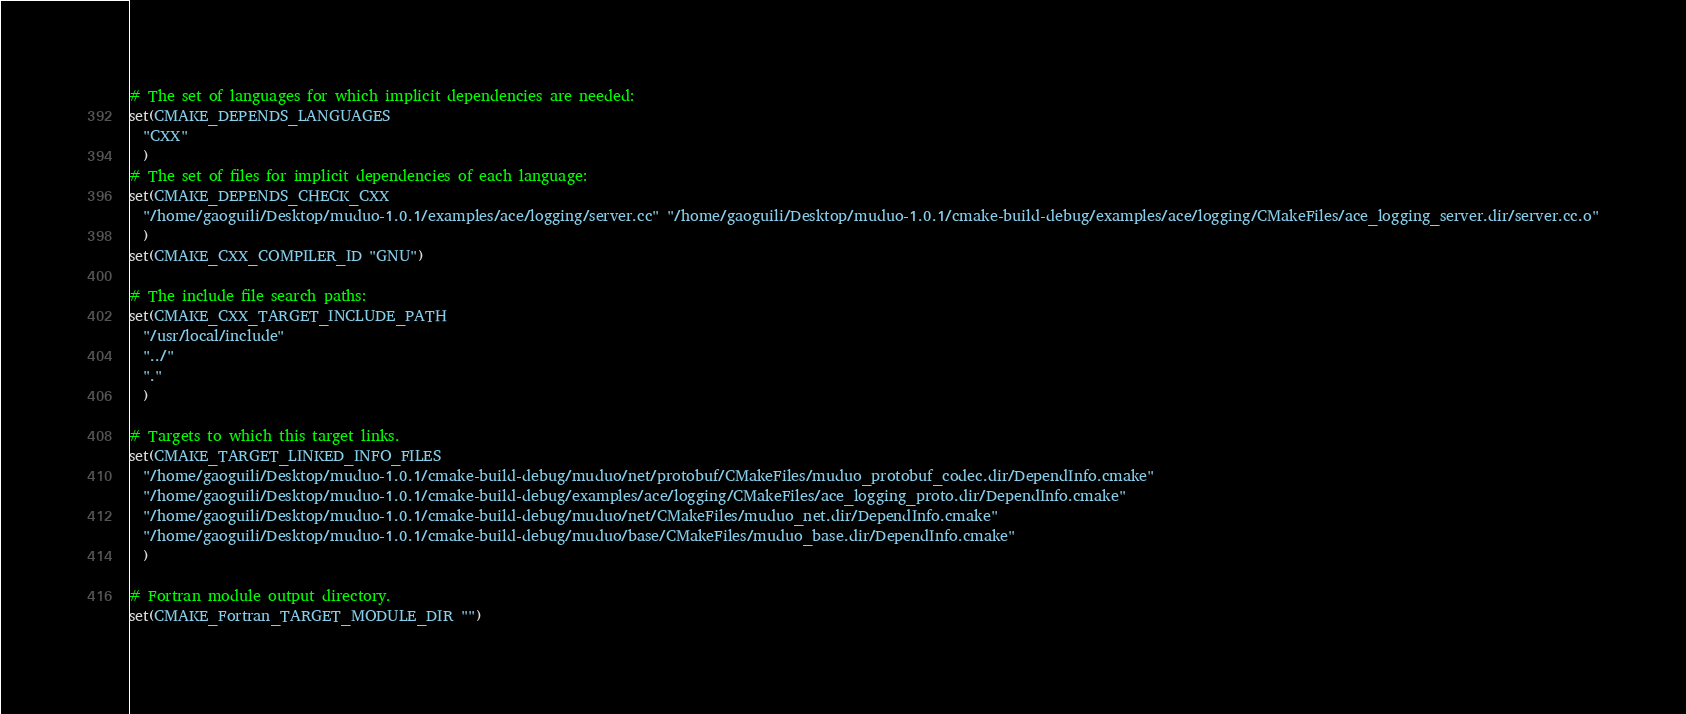Convert code to text. <code><loc_0><loc_0><loc_500><loc_500><_CMake_># The set of languages for which implicit dependencies are needed:
set(CMAKE_DEPENDS_LANGUAGES
  "CXX"
  )
# The set of files for implicit dependencies of each language:
set(CMAKE_DEPENDS_CHECK_CXX
  "/home/gaoguili/Desktop/muduo-1.0.1/examples/ace/logging/server.cc" "/home/gaoguili/Desktop/muduo-1.0.1/cmake-build-debug/examples/ace/logging/CMakeFiles/ace_logging_server.dir/server.cc.o"
  )
set(CMAKE_CXX_COMPILER_ID "GNU")

# The include file search paths:
set(CMAKE_CXX_TARGET_INCLUDE_PATH
  "/usr/local/include"
  "../"
  "."
  )

# Targets to which this target links.
set(CMAKE_TARGET_LINKED_INFO_FILES
  "/home/gaoguili/Desktop/muduo-1.0.1/cmake-build-debug/muduo/net/protobuf/CMakeFiles/muduo_protobuf_codec.dir/DependInfo.cmake"
  "/home/gaoguili/Desktop/muduo-1.0.1/cmake-build-debug/examples/ace/logging/CMakeFiles/ace_logging_proto.dir/DependInfo.cmake"
  "/home/gaoguili/Desktop/muduo-1.0.1/cmake-build-debug/muduo/net/CMakeFiles/muduo_net.dir/DependInfo.cmake"
  "/home/gaoguili/Desktop/muduo-1.0.1/cmake-build-debug/muduo/base/CMakeFiles/muduo_base.dir/DependInfo.cmake"
  )

# Fortran module output directory.
set(CMAKE_Fortran_TARGET_MODULE_DIR "")
</code> 